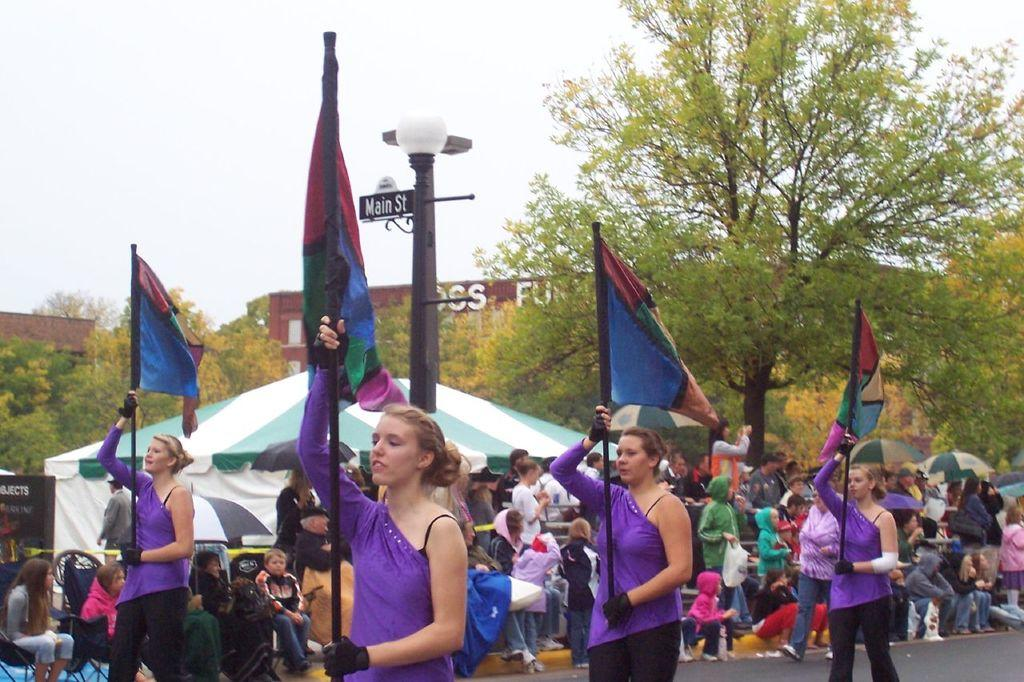How many people can be seen in the image? There are people in the image, but the exact number is not specified. What are some of the people holding in the image? Some of the people are holding flags in the image. What type of shelter is visible in the image? There is a tent in the image. What type of structures can be seen in the background of the image? There are buildings in the image. What type of vegetation is present in the image? There are trees in the image. What type of seating is available in the image? There are chairs in the image. What can be seen in the sky in the image? The sky is visible in the image. What type of flower is growing near the peace sign in the image? There is no peace sign or flower present in the image. 